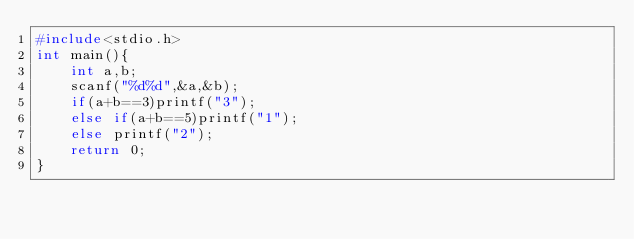<code> <loc_0><loc_0><loc_500><loc_500><_C_>#include<stdio.h>
int main(){
    int a,b;
    scanf("%d%d",&a,&b);
    if(a+b==3)printf("3");
    else if(a+b==5)printf("1");
    else printf("2");
    return 0;
}</code> 